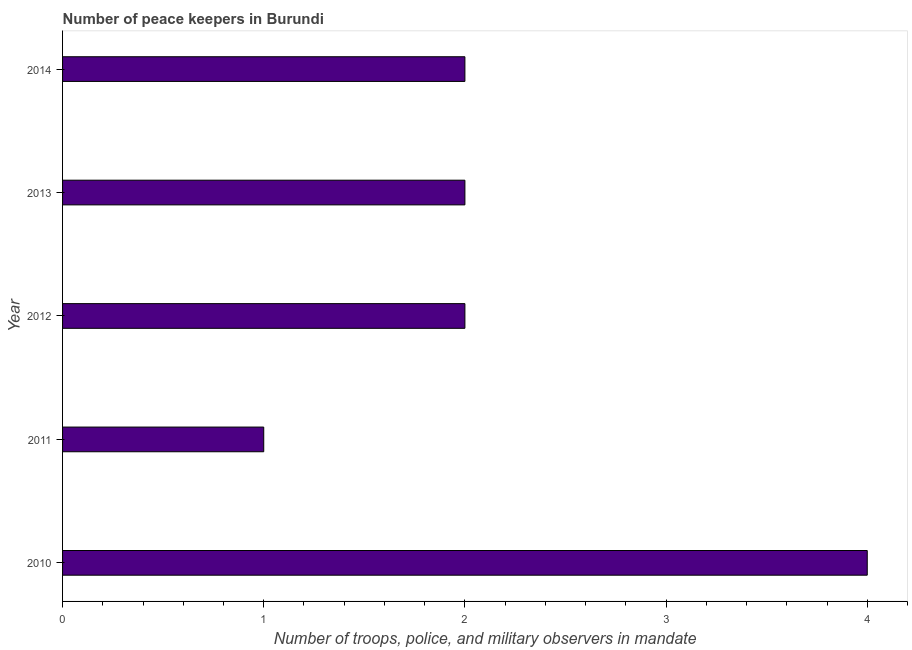What is the title of the graph?
Give a very brief answer. Number of peace keepers in Burundi. What is the label or title of the X-axis?
Offer a terse response. Number of troops, police, and military observers in mandate. What is the label or title of the Y-axis?
Give a very brief answer. Year. Across all years, what is the maximum number of peace keepers?
Ensure brevity in your answer.  4. In which year was the number of peace keepers minimum?
Ensure brevity in your answer.  2011. What is the sum of the number of peace keepers?
Offer a very short reply. 11. What is the difference between the number of peace keepers in 2010 and 2013?
Your response must be concise. 2. What is the median number of peace keepers?
Your response must be concise. 2. Is the difference between the number of peace keepers in 2012 and 2014 greater than the difference between any two years?
Make the answer very short. No. What is the difference between the highest and the second highest number of peace keepers?
Provide a succinct answer. 2. Is the sum of the number of peace keepers in 2010 and 2012 greater than the maximum number of peace keepers across all years?
Your response must be concise. Yes. What is the difference between the highest and the lowest number of peace keepers?
Offer a very short reply. 3. In how many years, is the number of peace keepers greater than the average number of peace keepers taken over all years?
Offer a very short reply. 1. Are all the bars in the graph horizontal?
Offer a terse response. Yes. Are the values on the major ticks of X-axis written in scientific E-notation?
Provide a succinct answer. No. What is the Number of troops, police, and military observers in mandate in 2010?
Give a very brief answer. 4. What is the Number of troops, police, and military observers in mandate of 2012?
Keep it short and to the point. 2. What is the difference between the Number of troops, police, and military observers in mandate in 2010 and 2011?
Provide a succinct answer. 3. What is the difference between the Number of troops, police, and military observers in mandate in 2010 and 2013?
Give a very brief answer. 2. What is the difference between the Number of troops, police, and military observers in mandate in 2012 and 2014?
Your answer should be compact. 0. What is the difference between the Number of troops, police, and military observers in mandate in 2013 and 2014?
Give a very brief answer. 0. What is the ratio of the Number of troops, police, and military observers in mandate in 2010 to that in 2011?
Keep it short and to the point. 4. What is the ratio of the Number of troops, police, and military observers in mandate in 2010 to that in 2012?
Your response must be concise. 2. What is the ratio of the Number of troops, police, and military observers in mandate in 2010 to that in 2013?
Your response must be concise. 2. What is the ratio of the Number of troops, police, and military observers in mandate in 2012 to that in 2013?
Provide a succinct answer. 1. What is the ratio of the Number of troops, police, and military observers in mandate in 2013 to that in 2014?
Offer a terse response. 1. 